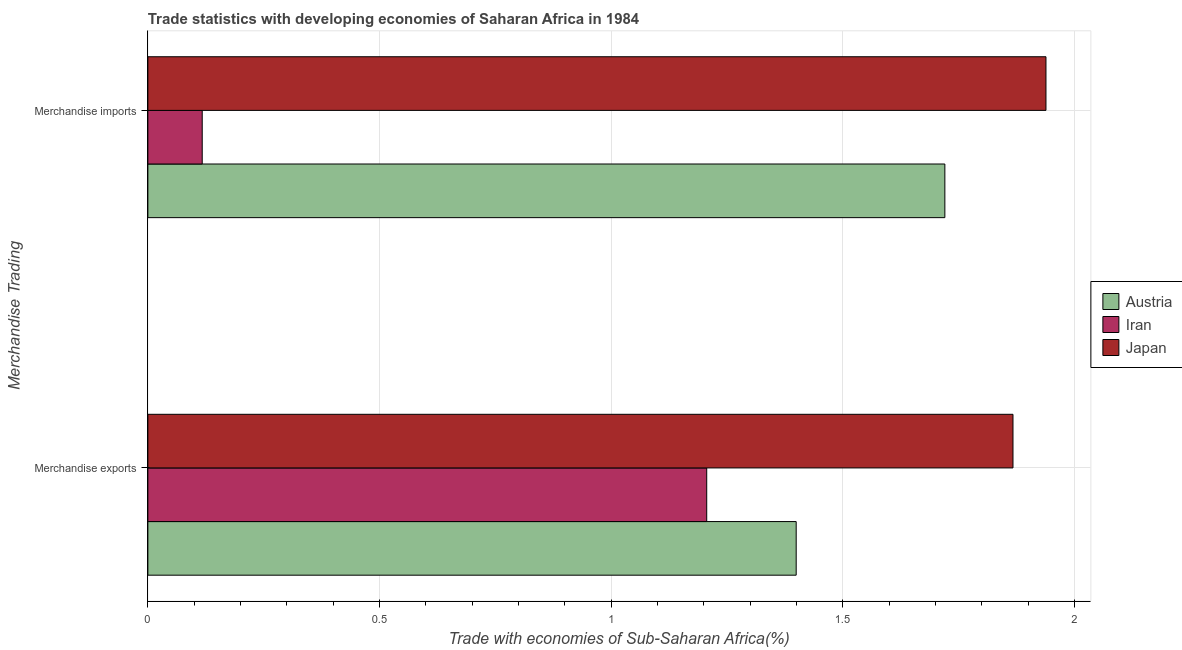How many different coloured bars are there?
Make the answer very short. 3. How many groups of bars are there?
Give a very brief answer. 2. What is the merchandise imports in Austria?
Give a very brief answer. 1.72. Across all countries, what is the maximum merchandise exports?
Your answer should be very brief. 1.87. Across all countries, what is the minimum merchandise exports?
Keep it short and to the point. 1.21. In which country was the merchandise imports maximum?
Ensure brevity in your answer.  Japan. In which country was the merchandise imports minimum?
Your response must be concise. Iran. What is the total merchandise exports in the graph?
Your answer should be compact. 4.47. What is the difference between the merchandise exports in Austria and that in Japan?
Provide a short and direct response. -0.47. What is the difference between the merchandise exports in Japan and the merchandise imports in Austria?
Your answer should be very brief. 0.15. What is the average merchandise exports per country?
Your answer should be very brief. 1.49. What is the difference between the merchandise exports and merchandise imports in Iran?
Offer a terse response. 1.09. What is the ratio of the merchandise exports in Japan to that in Iran?
Your answer should be very brief. 1.55. In how many countries, is the merchandise imports greater than the average merchandise imports taken over all countries?
Provide a succinct answer. 2. What does the 2nd bar from the bottom in Merchandise exports represents?
Provide a succinct answer. Iran. How many bars are there?
Your answer should be very brief. 6. Are all the bars in the graph horizontal?
Offer a terse response. Yes. How many countries are there in the graph?
Offer a terse response. 3. Are the values on the major ticks of X-axis written in scientific E-notation?
Offer a very short reply. No. Does the graph contain grids?
Provide a short and direct response. Yes. Where does the legend appear in the graph?
Provide a succinct answer. Center right. How many legend labels are there?
Your answer should be very brief. 3. What is the title of the graph?
Make the answer very short. Trade statistics with developing economies of Saharan Africa in 1984. What is the label or title of the X-axis?
Keep it short and to the point. Trade with economies of Sub-Saharan Africa(%). What is the label or title of the Y-axis?
Your answer should be compact. Merchandise Trading. What is the Trade with economies of Sub-Saharan Africa(%) of Austria in Merchandise exports?
Your answer should be compact. 1.4. What is the Trade with economies of Sub-Saharan Africa(%) of Iran in Merchandise exports?
Offer a terse response. 1.21. What is the Trade with economies of Sub-Saharan Africa(%) in Japan in Merchandise exports?
Your answer should be very brief. 1.87. What is the Trade with economies of Sub-Saharan Africa(%) in Austria in Merchandise imports?
Your answer should be very brief. 1.72. What is the Trade with economies of Sub-Saharan Africa(%) in Iran in Merchandise imports?
Ensure brevity in your answer.  0.12. What is the Trade with economies of Sub-Saharan Africa(%) of Japan in Merchandise imports?
Ensure brevity in your answer.  1.94. Across all Merchandise Trading, what is the maximum Trade with economies of Sub-Saharan Africa(%) of Austria?
Make the answer very short. 1.72. Across all Merchandise Trading, what is the maximum Trade with economies of Sub-Saharan Africa(%) of Iran?
Give a very brief answer. 1.21. Across all Merchandise Trading, what is the maximum Trade with economies of Sub-Saharan Africa(%) in Japan?
Provide a short and direct response. 1.94. Across all Merchandise Trading, what is the minimum Trade with economies of Sub-Saharan Africa(%) of Austria?
Offer a very short reply. 1.4. Across all Merchandise Trading, what is the minimum Trade with economies of Sub-Saharan Africa(%) in Iran?
Offer a very short reply. 0.12. Across all Merchandise Trading, what is the minimum Trade with economies of Sub-Saharan Africa(%) in Japan?
Provide a short and direct response. 1.87. What is the total Trade with economies of Sub-Saharan Africa(%) in Austria in the graph?
Your answer should be very brief. 3.12. What is the total Trade with economies of Sub-Saharan Africa(%) in Iran in the graph?
Your answer should be compact. 1.32. What is the total Trade with economies of Sub-Saharan Africa(%) of Japan in the graph?
Provide a short and direct response. 3.81. What is the difference between the Trade with economies of Sub-Saharan Africa(%) of Austria in Merchandise exports and that in Merchandise imports?
Keep it short and to the point. -0.32. What is the difference between the Trade with economies of Sub-Saharan Africa(%) of Iran in Merchandise exports and that in Merchandise imports?
Offer a very short reply. 1.09. What is the difference between the Trade with economies of Sub-Saharan Africa(%) of Japan in Merchandise exports and that in Merchandise imports?
Your answer should be compact. -0.07. What is the difference between the Trade with economies of Sub-Saharan Africa(%) in Austria in Merchandise exports and the Trade with economies of Sub-Saharan Africa(%) in Iran in Merchandise imports?
Give a very brief answer. 1.28. What is the difference between the Trade with economies of Sub-Saharan Africa(%) in Austria in Merchandise exports and the Trade with economies of Sub-Saharan Africa(%) in Japan in Merchandise imports?
Make the answer very short. -0.54. What is the difference between the Trade with economies of Sub-Saharan Africa(%) of Iran in Merchandise exports and the Trade with economies of Sub-Saharan Africa(%) of Japan in Merchandise imports?
Make the answer very short. -0.73. What is the average Trade with economies of Sub-Saharan Africa(%) of Austria per Merchandise Trading?
Your answer should be compact. 1.56. What is the average Trade with economies of Sub-Saharan Africa(%) in Iran per Merchandise Trading?
Ensure brevity in your answer.  0.66. What is the average Trade with economies of Sub-Saharan Africa(%) of Japan per Merchandise Trading?
Provide a succinct answer. 1.9. What is the difference between the Trade with economies of Sub-Saharan Africa(%) of Austria and Trade with economies of Sub-Saharan Africa(%) of Iran in Merchandise exports?
Offer a very short reply. 0.19. What is the difference between the Trade with economies of Sub-Saharan Africa(%) of Austria and Trade with economies of Sub-Saharan Africa(%) of Japan in Merchandise exports?
Offer a very short reply. -0.47. What is the difference between the Trade with economies of Sub-Saharan Africa(%) in Iran and Trade with economies of Sub-Saharan Africa(%) in Japan in Merchandise exports?
Offer a terse response. -0.66. What is the difference between the Trade with economies of Sub-Saharan Africa(%) in Austria and Trade with economies of Sub-Saharan Africa(%) in Iran in Merchandise imports?
Your response must be concise. 1.6. What is the difference between the Trade with economies of Sub-Saharan Africa(%) in Austria and Trade with economies of Sub-Saharan Africa(%) in Japan in Merchandise imports?
Make the answer very short. -0.22. What is the difference between the Trade with economies of Sub-Saharan Africa(%) in Iran and Trade with economies of Sub-Saharan Africa(%) in Japan in Merchandise imports?
Provide a short and direct response. -1.82. What is the ratio of the Trade with economies of Sub-Saharan Africa(%) of Austria in Merchandise exports to that in Merchandise imports?
Offer a terse response. 0.81. What is the ratio of the Trade with economies of Sub-Saharan Africa(%) of Iran in Merchandise exports to that in Merchandise imports?
Offer a terse response. 10.28. What is the ratio of the Trade with economies of Sub-Saharan Africa(%) of Japan in Merchandise exports to that in Merchandise imports?
Keep it short and to the point. 0.96. What is the difference between the highest and the second highest Trade with economies of Sub-Saharan Africa(%) of Austria?
Ensure brevity in your answer.  0.32. What is the difference between the highest and the second highest Trade with economies of Sub-Saharan Africa(%) of Iran?
Provide a succinct answer. 1.09. What is the difference between the highest and the second highest Trade with economies of Sub-Saharan Africa(%) of Japan?
Offer a very short reply. 0.07. What is the difference between the highest and the lowest Trade with economies of Sub-Saharan Africa(%) in Austria?
Your answer should be very brief. 0.32. What is the difference between the highest and the lowest Trade with economies of Sub-Saharan Africa(%) in Iran?
Provide a succinct answer. 1.09. What is the difference between the highest and the lowest Trade with economies of Sub-Saharan Africa(%) in Japan?
Offer a very short reply. 0.07. 